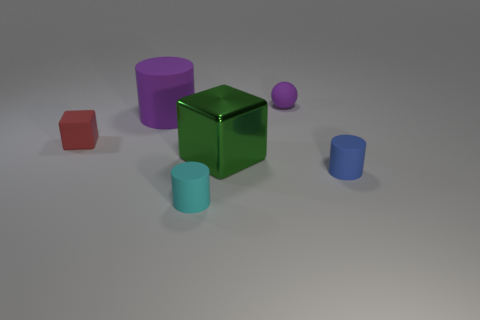Is there anything else that has the same material as the green cube?
Offer a very short reply. No. How many tiny objects are red blocks or purple objects?
Offer a very short reply. 2. Is the number of big metallic cubes that are behind the big green block less than the number of rubber cylinders in front of the large matte cylinder?
Provide a short and direct response. Yes. How many objects are purple cylinders or rubber blocks?
Keep it short and to the point. 2. How many purple spheres are in front of the matte block?
Your response must be concise. 0. Does the large shiny cube have the same color as the small sphere?
Keep it short and to the point. No. The tiny cyan thing that is made of the same material as the small sphere is what shape?
Ensure brevity in your answer.  Cylinder. Does the purple rubber object that is left of the big green cube have the same shape as the cyan rubber object?
Your answer should be compact. Yes. What number of purple objects are spheres or big metallic cylinders?
Make the answer very short. 1. Is the number of green shiny things that are to the right of the small purple object the same as the number of purple matte balls that are to the left of the tiny cyan matte cylinder?
Make the answer very short. Yes. 